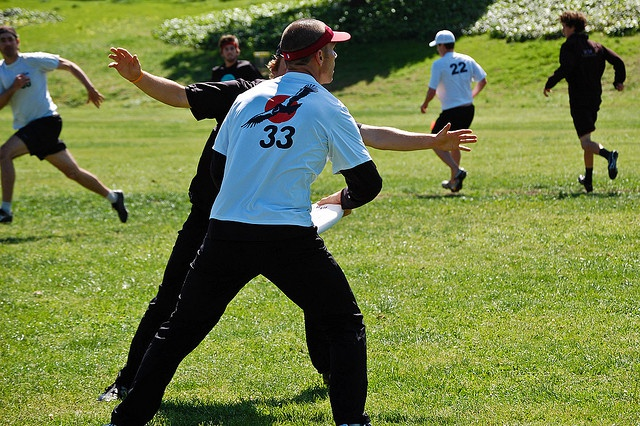Describe the objects in this image and their specific colors. I can see people in olive, black, gray, and maroon tones, people in olive, black, maroon, and gray tones, people in olive, black, and gray tones, people in olive, black, and maroon tones, and people in olive, black, gray, and maroon tones in this image. 